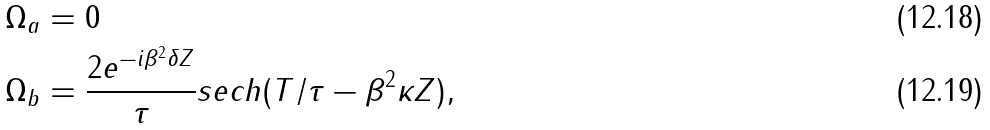<formula> <loc_0><loc_0><loc_500><loc_500>\Omega _ { a } & = 0 \\ \Omega _ { b } & = \frac { 2 e ^ { - i \beta ^ { 2 } \delta Z } } { \tau } s e c h ( T / \tau - \beta ^ { 2 } \kappa Z ) ,</formula> 